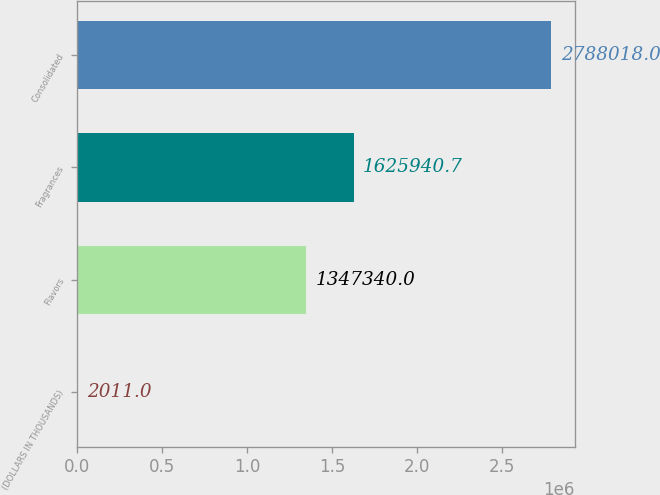Convert chart. <chart><loc_0><loc_0><loc_500><loc_500><bar_chart><fcel>(DOLLARS IN THOUSANDS)<fcel>Flavors<fcel>Fragrances<fcel>Consolidated<nl><fcel>2011<fcel>1.34734e+06<fcel>1.62594e+06<fcel>2.78802e+06<nl></chart> 